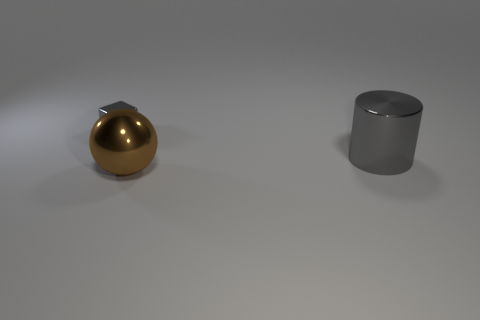There is a shiny thing that is the same color as the cube; what shape is it?
Provide a succinct answer. Cylinder. What number of small gray objects are there?
Your response must be concise. 1. What is the shape of the big brown object that is the same material as the gray cube?
Provide a short and direct response. Sphere. Are there any other things of the same color as the big cylinder?
Give a very brief answer. Yes. Is the color of the tiny cube the same as the big metallic thing behind the brown metal object?
Ensure brevity in your answer.  Yes. Is the number of big metallic cylinders that are left of the large brown sphere less than the number of gray blocks?
Ensure brevity in your answer.  Yes. What number of other objects are there of the same size as the brown metallic sphere?
Your answer should be very brief. 1. There is a brown ball; is it the same size as the gray thing that is behind the metallic cylinder?
Offer a terse response. No. What is the shape of the large shiny thing that is to the left of the gray metal object right of the gray object to the left of the brown shiny sphere?
Provide a short and direct response. Sphere. Are there fewer green matte balls than brown metallic spheres?
Provide a succinct answer. Yes. 